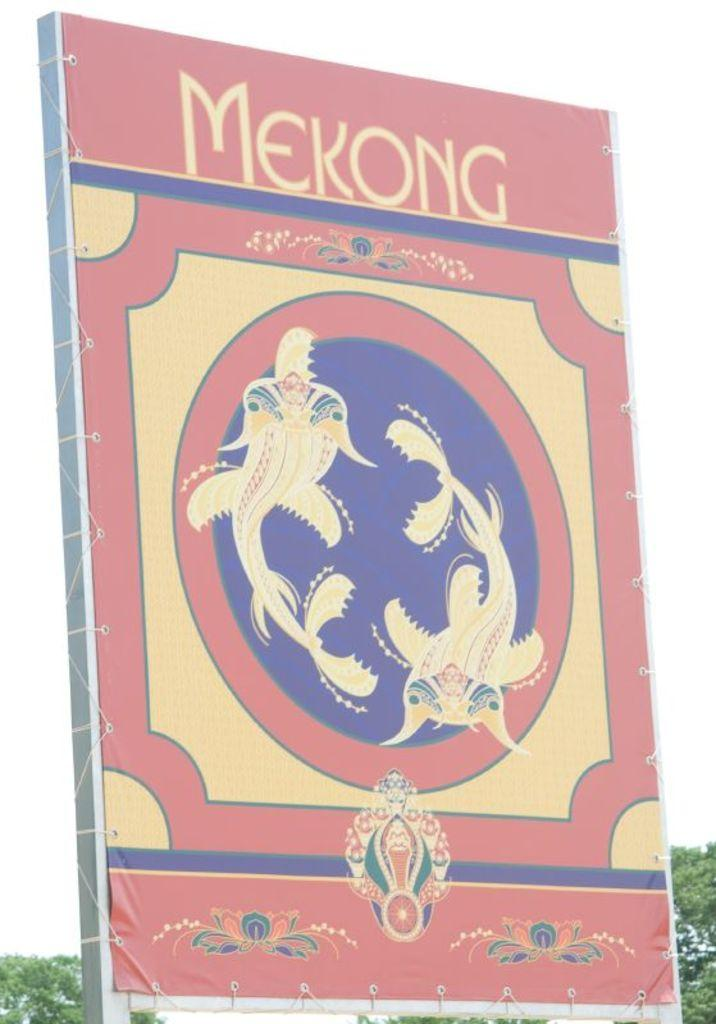Provide a one-sentence caption for the provided image. A picture of a colorful book with the title Mekong. 